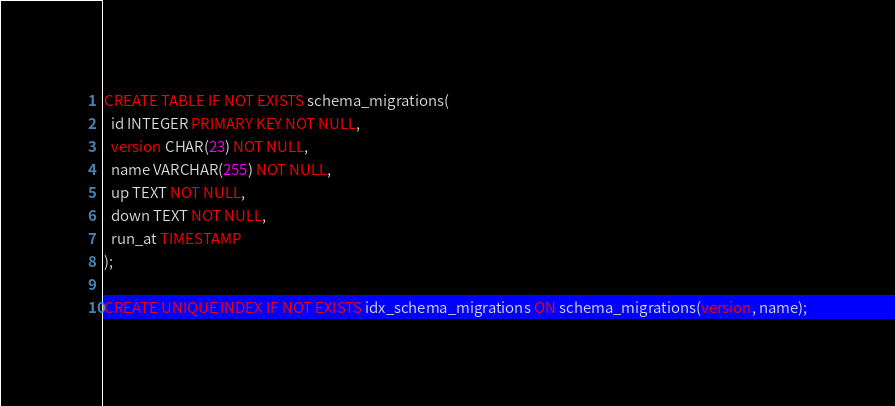Convert code to text. <code><loc_0><loc_0><loc_500><loc_500><_SQL_>CREATE TABLE IF NOT EXISTS schema_migrations(
  id INTEGER PRIMARY KEY NOT NULL,
  version CHAR(23) NOT NULL,
  name VARCHAR(255) NOT NULL,
  up TEXT NOT NULL,
  down TEXT NOT NULL,
  run_at TIMESTAMP
);

CREATE UNIQUE INDEX IF NOT EXISTS idx_schema_migrations ON schema_migrations(version, name);
</code> 